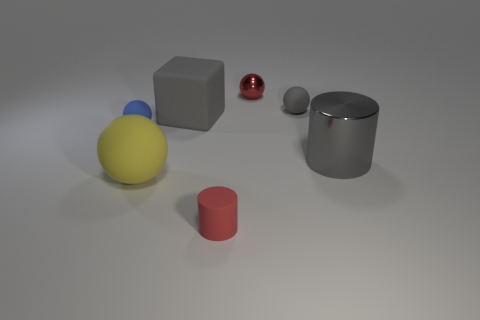Subtract all red balls. How many balls are left? 3 Add 3 yellow shiny objects. How many objects exist? 10 Subtract all blue balls. How many balls are left? 3 Subtract all purple spheres. How many red cylinders are left? 1 Add 6 small metallic spheres. How many small metallic spheres exist? 7 Subtract 1 gray cylinders. How many objects are left? 6 Subtract all balls. How many objects are left? 3 Subtract all yellow cylinders. Subtract all green balls. How many cylinders are left? 2 Subtract all blue spheres. Subtract all metallic things. How many objects are left? 4 Add 1 large cubes. How many large cubes are left? 2 